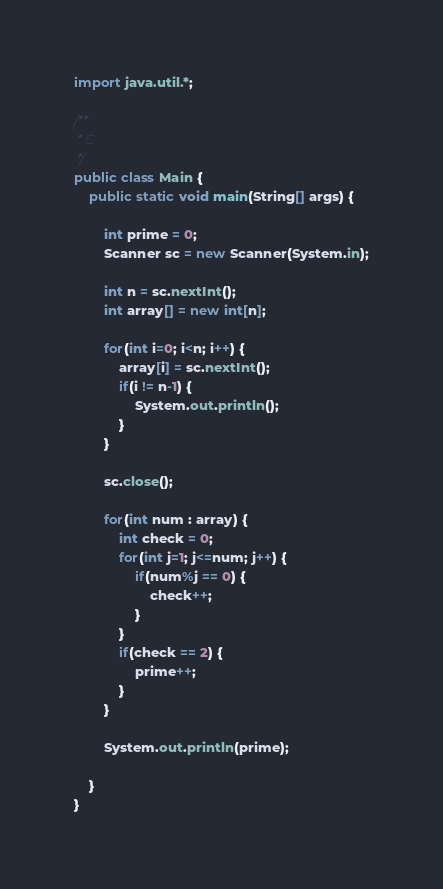Convert code to text. <code><loc_0><loc_0><loc_500><loc_500><_Java_>import java.util.*;

/**
 * C
 */
public class Main {
    public static void main(String[] args) {
        
        int prime = 0;
        Scanner sc = new Scanner(System.in);

        int n = sc.nextInt();
        int array[] = new int[n];

        for(int i=0; i<n; i++) {
            array[i] = sc.nextInt();
            if(i != n-1) {
                System.out.println();
            }
        }

        sc.close();

        for(int num : array) {
            int check = 0;
            for(int j=1; j<=num; j++) {
                if(num%j == 0) {
                    check++;
                }
            }
            if(check == 2) {
                prime++;
            }
        }

        System.out.println(prime);

    }
}

</code> 